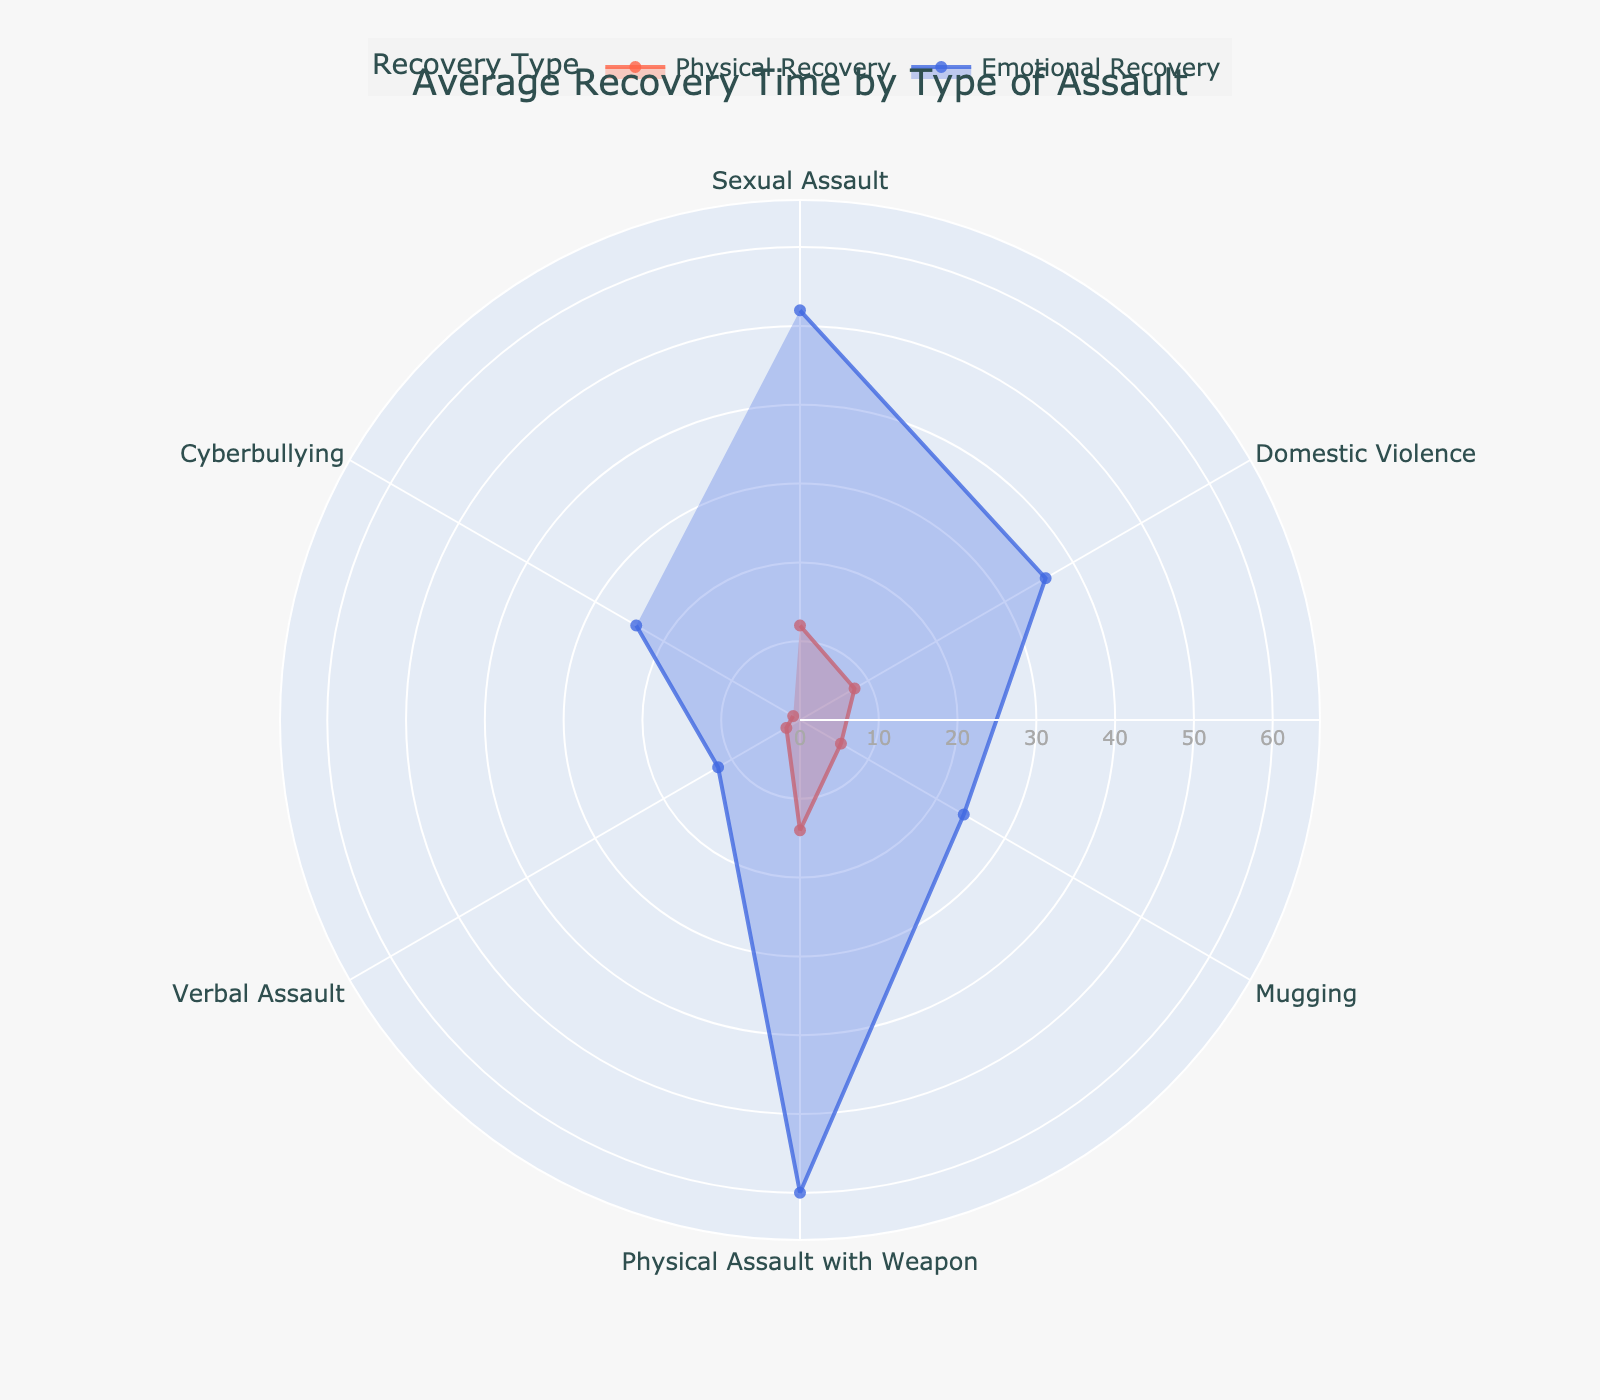What's the title of the chart? The title is located at the top center of the figure. It provides an overview of what the chart is about.
Answer: Average Recovery Time by Type of Assault Which type of assault has the highest average physical recovery time? The highest point on the 'Physical Recovery' trace indicates this. The 'Physical Assault with Weapon' category has the highest value at 14 weeks.
Answer: Physical Assault with Weapon How does the average emotional recovery time for verbal assault compare to the physical recovery time for the same type? First, locate the 'Verbal Assault' segment on both traces. The emotional recovery time is 12 weeks, while the physical recovery time is 2 weeks. Emotional recovery time is greater.
Answer: 12 weeks vs. 2 weeks What's the difference between the average emotional recovery time for sexual assault and domestic violence? Sexual Assault has an average emotional recovery time of 52 weeks and Domestic Violence has 36 weeks. Calculate the difference: 52 - 36.
Answer: 16 weeks Which type of assault has the smallest average emotional recovery time? Look at the smallest point on the 'Emotional Recovery' trace. The 'Verbal Assault' segment shows the smallest value at 12 weeks.
Answer: Verbal Assault What is the combined average physical and emotional recovery time for mugging? For Mugging, add the physical (6 weeks) and emotional (24 weeks) recovery times together: 6 + 24.
Answer: 30 weeks How many types of assault are analyzed in this chart? Count the number of distinct categories noted on the radial axis. There are 6 types of assault listed.
Answer: 6 types Which type of assault shows a greater emotional toll compared to physical recovery by the greatest margin? Compare the difference between emotional and physical recovery times for all types. 'Physical Assault with Weapon' shows the largest difference (60 weeks - 14 weeks).
Answer: Physical Assault with Weapon 